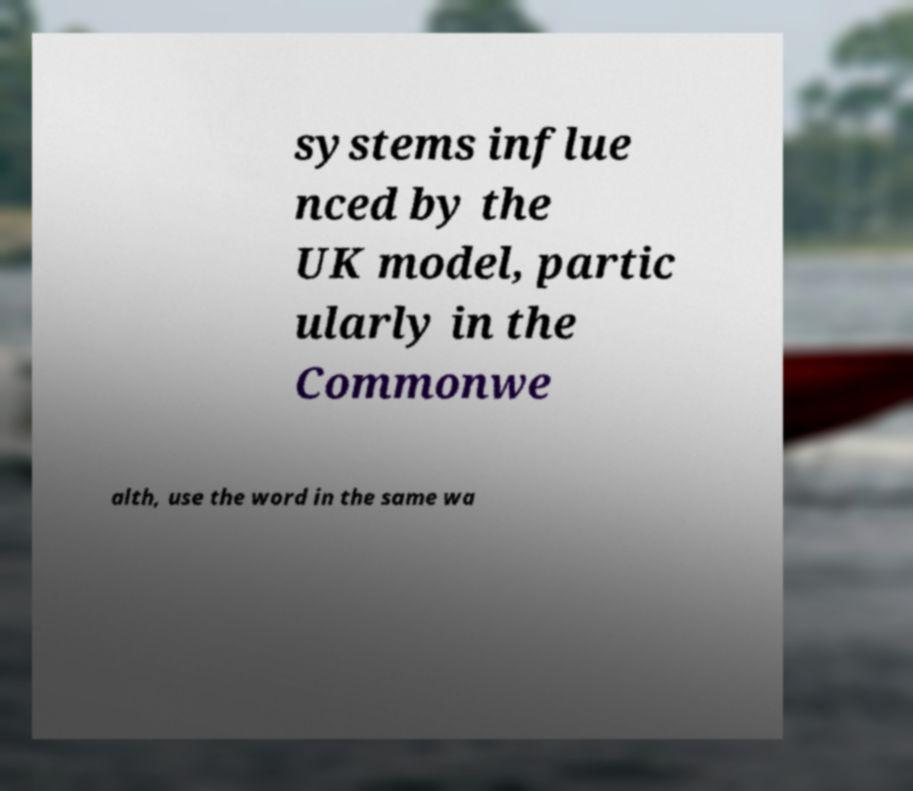Can you accurately transcribe the text from the provided image for me? systems influe nced by the UK model, partic ularly in the Commonwe alth, use the word in the same wa 